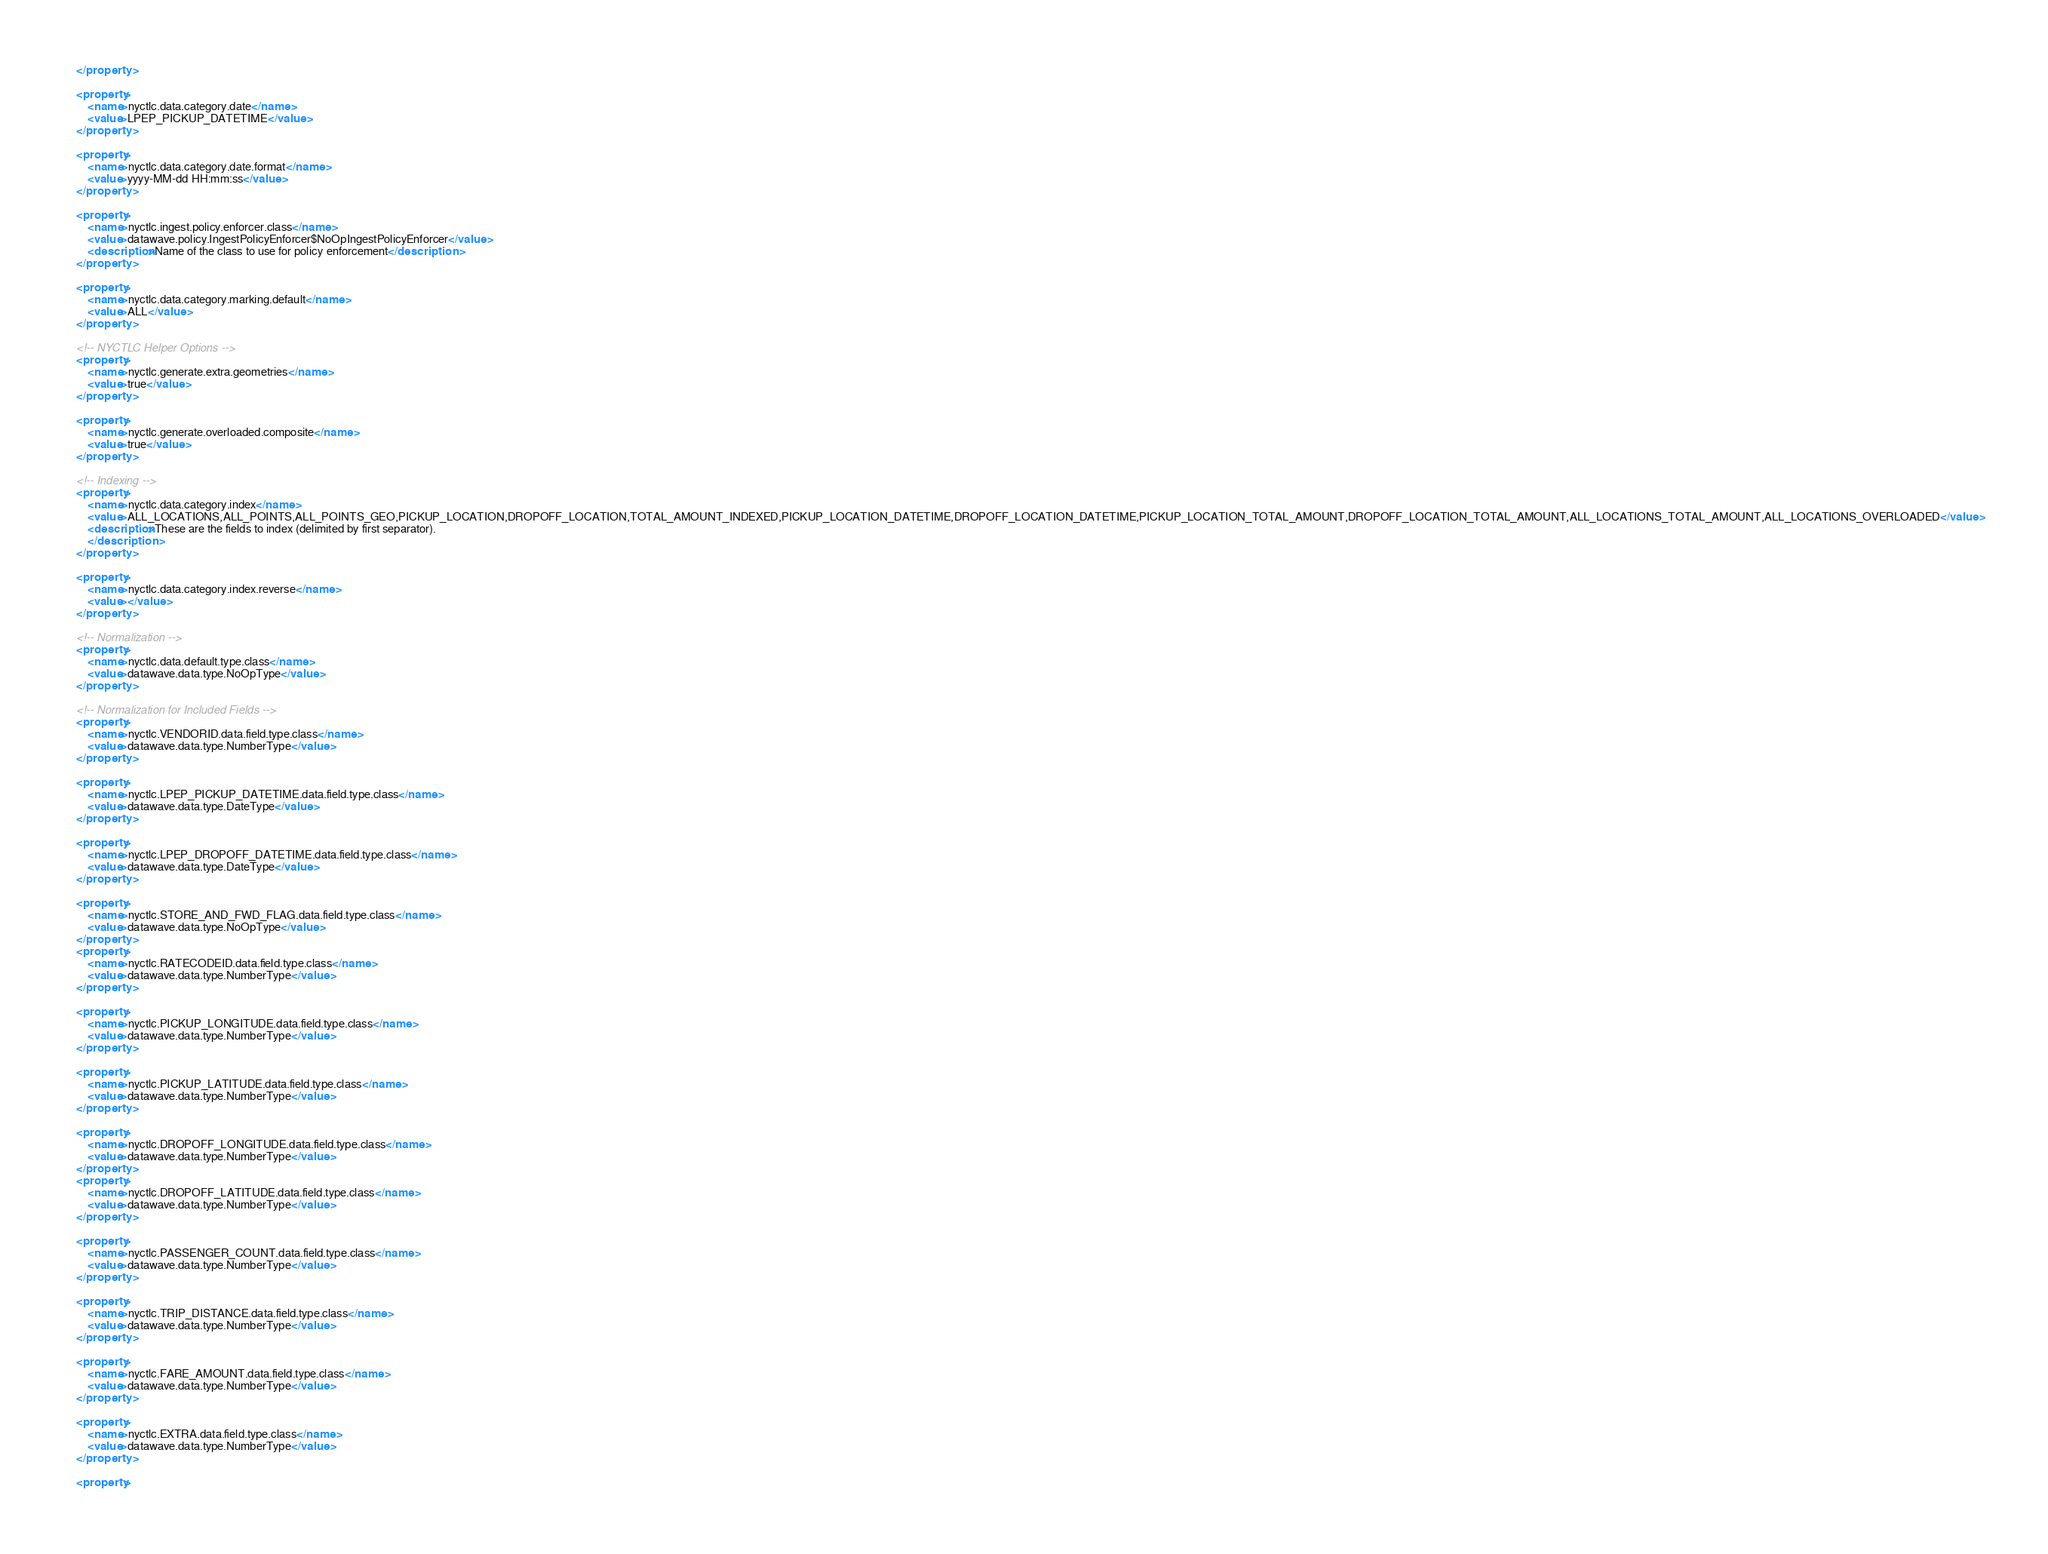Convert code to text. <code><loc_0><loc_0><loc_500><loc_500><_XML_>    </property>

    <property>
        <name>nyctlc.data.category.date</name>
        <value>LPEP_PICKUP_DATETIME</value>
    </property>

    <property>
        <name>nyctlc.data.category.date.format</name>
        <value>yyyy-MM-dd HH:mm:ss</value>
    </property>

    <property>
        <name>nyctlc.ingest.policy.enforcer.class</name>
        <value>datawave.policy.IngestPolicyEnforcer$NoOpIngestPolicyEnforcer</value>
        <description>Name of the class to use for policy enforcement</description>
    </property>

    <property>
        <name>nyctlc.data.category.marking.default</name>
        <value>ALL</value>
    </property>

    <!-- NYCTLC Helper Options -->
    <property>
        <name>nyctlc.generate.extra.geometries</name>
        <value>true</value>
    </property>

    <property>
        <name>nyctlc.generate.overloaded.composite</name>
        <value>true</value>
    </property>

    <!-- Indexing -->
    <property>
        <name>nyctlc.data.category.index</name>
        <value>ALL_LOCATIONS,ALL_POINTS,ALL_POINTS_GEO,PICKUP_LOCATION,DROPOFF_LOCATION,TOTAL_AMOUNT_INDEXED,PICKUP_LOCATION_DATETIME,DROPOFF_LOCATION_DATETIME,PICKUP_LOCATION_TOTAL_AMOUNT,DROPOFF_LOCATION_TOTAL_AMOUNT,ALL_LOCATIONS_TOTAL_AMOUNT,ALL_LOCATIONS_OVERLOADED</value>
        <description>These are the fields to index (delimited by first separator).
        </description>
    </property>

    <property>
        <name>nyctlc.data.category.index.reverse</name>
        <value></value>
    </property>

    <!-- Normalization -->
    <property>
        <name>nyctlc.data.default.type.class</name>
        <value>datawave.data.type.NoOpType</value>
    </property>

    <!-- Normalization for Included Fields -->
    <property>
        <name>nyctlc.VENDORID.data.field.type.class</name>
        <value>datawave.data.type.NumberType</value>
    </property>

    <property>
        <name>nyctlc.LPEP_PICKUP_DATETIME.data.field.type.class</name>
        <value>datawave.data.type.DateType</value>
    </property>

    <property>
        <name>nyctlc.LPEP_DROPOFF_DATETIME.data.field.type.class</name>
        <value>datawave.data.type.DateType</value>
    </property>

    <property>
        <name>nyctlc.STORE_AND_FWD_FLAG.data.field.type.class</name>
        <value>datawave.data.type.NoOpType</value>
    </property>
    <property>
        <name>nyctlc.RATECODEID.data.field.type.class</name>
        <value>datawave.data.type.NumberType</value>
    </property>

    <property>
        <name>nyctlc.PICKUP_LONGITUDE.data.field.type.class</name>
        <value>datawave.data.type.NumberType</value>
    </property>

    <property>
        <name>nyctlc.PICKUP_LATITUDE.data.field.type.class</name>
        <value>datawave.data.type.NumberType</value>
    </property>

    <property>
        <name>nyctlc.DROPOFF_LONGITUDE.data.field.type.class</name>
        <value>datawave.data.type.NumberType</value>
    </property>
    <property>
        <name>nyctlc.DROPOFF_LATITUDE.data.field.type.class</name>
        <value>datawave.data.type.NumberType</value>
    </property>

    <property>
        <name>nyctlc.PASSENGER_COUNT.data.field.type.class</name>
        <value>datawave.data.type.NumberType</value>
    </property>

    <property>
        <name>nyctlc.TRIP_DISTANCE.data.field.type.class</name>
        <value>datawave.data.type.NumberType</value>
    </property>

    <property>
        <name>nyctlc.FARE_AMOUNT.data.field.type.class</name>
        <value>datawave.data.type.NumberType</value>
    </property>

    <property>
        <name>nyctlc.EXTRA.data.field.type.class</name>
        <value>datawave.data.type.NumberType</value>
    </property>

    <property></code> 